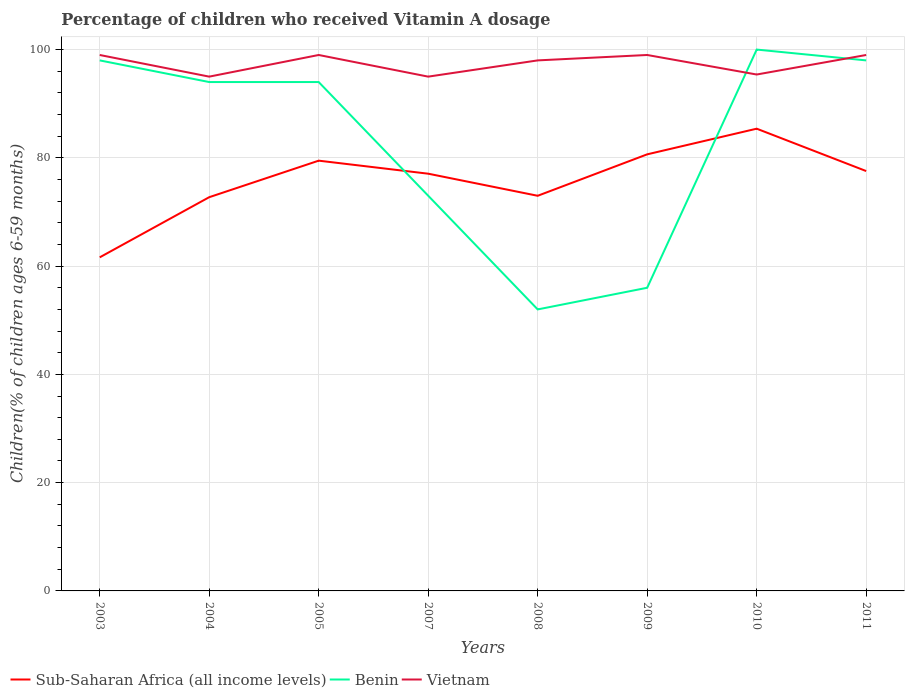How many different coloured lines are there?
Keep it short and to the point. 3. Across all years, what is the maximum percentage of children who received Vitamin A dosage in Sub-Saharan Africa (all income levels)?
Your answer should be compact. 61.62. What is the total percentage of children who received Vitamin A dosage in Sub-Saharan Africa (all income levels) in the graph?
Give a very brief answer. -7.66. What is the difference between the highest and the second highest percentage of children who received Vitamin A dosage in Benin?
Your response must be concise. 48. What is the difference between the highest and the lowest percentage of children who received Vitamin A dosage in Sub-Saharan Africa (all income levels)?
Keep it short and to the point. 5. Are the values on the major ticks of Y-axis written in scientific E-notation?
Make the answer very short. No. Does the graph contain any zero values?
Your response must be concise. No. Does the graph contain grids?
Your response must be concise. Yes. How are the legend labels stacked?
Make the answer very short. Horizontal. What is the title of the graph?
Your answer should be compact. Percentage of children who received Vitamin A dosage. Does "Latin America(all income levels)" appear as one of the legend labels in the graph?
Keep it short and to the point. No. What is the label or title of the Y-axis?
Offer a very short reply. Children(% of children ages 6-59 months). What is the Children(% of children ages 6-59 months) of Sub-Saharan Africa (all income levels) in 2003?
Your answer should be compact. 61.62. What is the Children(% of children ages 6-59 months) of Sub-Saharan Africa (all income levels) in 2004?
Your response must be concise. 72.73. What is the Children(% of children ages 6-59 months) of Benin in 2004?
Provide a short and direct response. 94. What is the Children(% of children ages 6-59 months) of Sub-Saharan Africa (all income levels) in 2005?
Offer a terse response. 79.48. What is the Children(% of children ages 6-59 months) of Benin in 2005?
Offer a terse response. 94. What is the Children(% of children ages 6-59 months) of Vietnam in 2005?
Your response must be concise. 99. What is the Children(% of children ages 6-59 months) in Sub-Saharan Africa (all income levels) in 2007?
Make the answer very short. 77.07. What is the Children(% of children ages 6-59 months) in Benin in 2007?
Ensure brevity in your answer.  73. What is the Children(% of children ages 6-59 months) in Sub-Saharan Africa (all income levels) in 2008?
Your answer should be compact. 72.99. What is the Children(% of children ages 6-59 months) of Vietnam in 2008?
Keep it short and to the point. 98. What is the Children(% of children ages 6-59 months) in Sub-Saharan Africa (all income levels) in 2009?
Your answer should be very brief. 80.65. What is the Children(% of children ages 6-59 months) of Vietnam in 2009?
Offer a terse response. 99. What is the Children(% of children ages 6-59 months) of Sub-Saharan Africa (all income levels) in 2010?
Offer a very short reply. 85.38. What is the Children(% of children ages 6-59 months) of Benin in 2010?
Ensure brevity in your answer.  100. What is the Children(% of children ages 6-59 months) of Vietnam in 2010?
Your response must be concise. 95.39. What is the Children(% of children ages 6-59 months) of Sub-Saharan Africa (all income levels) in 2011?
Ensure brevity in your answer.  77.56. What is the Children(% of children ages 6-59 months) in Benin in 2011?
Provide a succinct answer. 98. What is the Children(% of children ages 6-59 months) in Vietnam in 2011?
Provide a short and direct response. 99. Across all years, what is the maximum Children(% of children ages 6-59 months) of Sub-Saharan Africa (all income levels)?
Ensure brevity in your answer.  85.38. Across all years, what is the maximum Children(% of children ages 6-59 months) of Benin?
Offer a very short reply. 100. Across all years, what is the minimum Children(% of children ages 6-59 months) of Sub-Saharan Africa (all income levels)?
Your answer should be very brief. 61.62. Across all years, what is the minimum Children(% of children ages 6-59 months) in Benin?
Offer a very short reply. 52. What is the total Children(% of children ages 6-59 months) in Sub-Saharan Africa (all income levels) in the graph?
Your answer should be compact. 607.48. What is the total Children(% of children ages 6-59 months) of Benin in the graph?
Keep it short and to the point. 665. What is the total Children(% of children ages 6-59 months) of Vietnam in the graph?
Give a very brief answer. 779.39. What is the difference between the Children(% of children ages 6-59 months) in Sub-Saharan Africa (all income levels) in 2003 and that in 2004?
Keep it short and to the point. -11.11. What is the difference between the Children(% of children ages 6-59 months) of Benin in 2003 and that in 2004?
Your response must be concise. 4. What is the difference between the Children(% of children ages 6-59 months) in Sub-Saharan Africa (all income levels) in 2003 and that in 2005?
Keep it short and to the point. -17.86. What is the difference between the Children(% of children ages 6-59 months) of Vietnam in 2003 and that in 2005?
Your answer should be very brief. 0. What is the difference between the Children(% of children ages 6-59 months) of Sub-Saharan Africa (all income levels) in 2003 and that in 2007?
Make the answer very short. -15.45. What is the difference between the Children(% of children ages 6-59 months) in Vietnam in 2003 and that in 2007?
Provide a short and direct response. 4. What is the difference between the Children(% of children ages 6-59 months) of Sub-Saharan Africa (all income levels) in 2003 and that in 2008?
Offer a terse response. -11.37. What is the difference between the Children(% of children ages 6-59 months) of Benin in 2003 and that in 2008?
Provide a short and direct response. 46. What is the difference between the Children(% of children ages 6-59 months) in Sub-Saharan Africa (all income levels) in 2003 and that in 2009?
Keep it short and to the point. -19.03. What is the difference between the Children(% of children ages 6-59 months) in Benin in 2003 and that in 2009?
Give a very brief answer. 42. What is the difference between the Children(% of children ages 6-59 months) in Sub-Saharan Africa (all income levels) in 2003 and that in 2010?
Your answer should be very brief. -23.77. What is the difference between the Children(% of children ages 6-59 months) in Benin in 2003 and that in 2010?
Offer a very short reply. -2. What is the difference between the Children(% of children ages 6-59 months) in Vietnam in 2003 and that in 2010?
Make the answer very short. 3.61. What is the difference between the Children(% of children ages 6-59 months) of Sub-Saharan Africa (all income levels) in 2003 and that in 2011?
Provide a short and direct response. -15.94. What is the difference between the Children(% of children ages 6-59 months) in Sub-Saharan Africa (all income levels) in 2004 and that in 2005?
Provide a succinct answer. -6.75. What is the difference between the Children(% of children ages 6-59 months) of Vietnam in 2004 and that in 2005?
Offer a terse response. -4. What is the difference between the Children(% of children ages 6-59 months) of Sub-Saharan Africa (all income levels) in 2004 and that in 2007?
Your response must be concise. -4.34. What is the difference between the Children(% of children ages 6-59 months) of Sub-Saharan Africa (all income levels) in 2004 and that in 2008?
Your response must be concise. -0.26. What is the difference between the Children(% of children ages 6-59 months) in Sub-Saharan Africa (all income levels) in 2004 and that in 2009?
Offer a very short reply. -7.92. What is the difference between the Children(% of children ages 6-59 months) in Benin in 2004 and that in 2009?
Your answer should be very brief. 38. What is the difference between the Children(% of children ages 6-59 months) of Sub-Saharan Africa (all income levels) in 2004 and that in 2010?
Your answer should be compact. -12.65. What is the difference between the Children(% of children ages 6-59 months) of Benin in 2004 and that in 2010?
Your response must be concise. -6. What is the difference between the Children(% of children ages 6-59 months) in Vietnam in 2004 and that in 2010?
Your answer should be very brief. -0.39. What is the difference between the Children(% of children ages 6-59 months) in Sub-Saharan Africa (all income levels) in 2004 and that in 2011?
Keep it short and to the point. -4.83. What is the difference between the Children(% of children ages 6-59 months) of Sub-Saharan Africa (all income levels) in 2005 and that in 2007?
Offer a terse response. 2.41. What is the difference between the Children(% of children ages 6-59 months) in Vietnam in 2005 and that in 2007?
Make the answer very short. 4. What is the difference between the Children(% of children ages 6-59 months) in Sub-Saharan Africa (all income levels) in 2005 and that in 2008?
Offer a very short reply. 6.49. What is the difference between the Children(% of children ages 6-59 months) of Benin in 2005 and that in 2008?
Your answer should be compact. 42. What is the difference between the Children(% of children ages 6-59 months) in Vietnam in 2005 and that in 2008?
Ensure brevity in your answer.  1. What is the difference between the Children(% of children ages 6-59 months) in Sub-Saharan Africa (all income levels) in 2005 and that in 2009?
Provide a succinct answer. -1.17. What is the difference between the Children(% of children ages 6-59 months) in Benin in 2005 and that in 2009?
Make the answer very short. 38. What is the difference between the Children(% of children ages 6-59 months) of Sub-Saharan Africa (all income levels) in 2005 and that in 2010?
Ensure brevity in your answer.  -5.91. What is the difference between the Children(% of children ages 6-59 months) in Vietnam in 2005 and that in 2010?
Make the answer very short. 3.61. What is the difference between the Children(% of children ages 6-59 months) of Sub-Saharan Africa (all income levels) in 2005 and that in 2011?
Your answer should be compact. 1.92. What is the difference between the Children(% of children ages 6-59 months) of Benin in 2005 and that in 2011?
Keep it short and to the point. -4. What is the difference between the Children(% of children ages 6-59 months) in Vietnam in 2005 and that in 2011?
Give a very brief answer. 0. What is the difference between the Children(% of children ages 6-59 months) in Sub-Saharan Africa (all income levels) in 2007 and that in 2008?
Your response must be concise. 4.08. What is the difference between the Children(% of children ages 6-59 months) in Benin in 2007 and that in 2008?
Provide a short and direct response. 21. What is the difference between the Children(% of children ages 6-59 months) in Sub-Saharan Africa (all income levels) in 2007 and that in 2009?
Keep it short and to the point. -3.58. What is the difference between the Children(% of children ages 6-59 months) of Vietnam in 2007 and that in 2009?
Your response must be concise. -4. What is the difference between the Children(% of children ages 6-59 months) of Sub-Saharan Africa (all income levels) in 2007 and that in 2010?
Your response must be concise. -8.31. What is the difference between the Children(% of children ages 6-59 months) of Benin in 2007 and that in 2010?
Ensure brevity in your answer.  -27. What is the difference between the Children(% of children ages 6-59 months) in Vietnam in 2007 and that in 2010?
Provide a short and direct response. -0.39. What is the difference between the Children(% of children ages 6-59 months) in Sub-Saharan Africa (all income levels) in 2007 and that in 2011?
Your answer should be compact. -0.49. What is the difference between the Children(% of children ages 6-59 months) of Vietnam in 2007 and that in 2011?
Make the answer very short. -4. What is the difference between the Children(% of children ages 6-59 months) in Sub-Saharan Africa (all income levels) in 2008 and that in 2009?
Offer a terse response. -7.66. What is the difference between the Children(% of children ages 6-59 months) of Sub-Saharan Africa (all income levels) in 2008 and that in 2010?
Ensure brevity in your answer.  -12.39. What is the difference between the Children(% of children ages 6-59 months) in Benin in 2008 and that in 2010?
Your response must be concise. -48. What is the difference between the Children(% of children ages 6-59 months) in Vietnam in 2008 and that in 2010?
Provide a succinct answer. 2.61. What is the difference between the Children(% of children ages 6-59 months) in Sub-Saharan Africa (all income levels) in 2008 and that in 2011?
Give a very brief answer. -4.57. What is the difference between the Children(% of children ages 6-59 months) in Benin in 2008 and that in 2011?
Offer a very short reply. -46. What is the difference between the Children(% of children ages 6-59 months) in Sub-Saharan Africa (all income levels) in 2009 and that in 2010?
Offer a very short reply. -4.74. What is the difference between the Children(% of children ages 6-59 months) in Benin in 2009 and that in 2010?
Give a very brief answer. -44. What is the difference between the Children(% of children ages 6-59 months) of Vietnam in 2009 and that in 2010?
Offer a very short reply. 3.61. What is the difference between the Children(% of children ages 6-59 months) of Sub-Saharan Africa (all income levels) in 2009 and that in 2011?
Give a very brief answer. 3.09. What is the difference between the Children(% of children ages 6-59 months) in Benin in 2009 and that in 2011?
Your response must be concise. -42. What is the difference between the Children(% of children ages 6-59 months) of Sub-Saharan Africa (all income levels) in 2010 and that in 2011?
Your answer should be compact. 7.83. What is the difference between the Children(% of children ages 6-59 months) in Vietnam in 2010 and that in 2011?
Provide a short and direct response. -3.61. What is the difference between the Children(% of children ages 6-59 months) in Sub-Saharan Africa (all income levels) in 2003 and the Children(% of children ages 6-59 months) in Benin in 2004?
Your answer should be compact. -32.38. What is the difference between the Children(% of children ages 6-59 months) of Sub-Saharan Africa (all income levels) in 2003 and the Children(% of children ages 6-59 months) of Vietnam in 2004?
Your answer should be compact. -33.38. What is the difference between the Children(% of children ages 6-59 months) of Benin in 2003 and the Children(% of children ages 6-59 months) of Vietnam in 2004?
Your answer should be compact. 3. What is the difference between the Children(% of children ages 6-59 months) of Sub-Saharan Africa (all income levels) in 2003 and the Children(% of children ages 6-59 months) of Benin in 2005?
Provide a short and direct response. -32.38. What is the difference between the Children(% of children ages 6-59 months) of Sub-Saharan Africa (all income levels) in 2003 and the Children(% of children ages 6-59 months) of Vietnam in 2005?
Provide a short and direct response. -37.38. What is the difference between the Children(% of children ages 6-59 months) in Benin in 2003 and the Children(% of children ages 6-59 months) in Vietnam in 2005?
Offer a very short reply. -1. What is the difference between the Children(% of children ages 6-59 months) of Sub-Saharan Africa (all income levels) in 2003 and the Children(% of children ages 6-59 months) of Benin in 2007?
Your answer should be very brief. -11.38. What is the difference between the Children(% of children ages 6-59 months) of Sub-Saharan Africa (all income levels) in 2003 and the Children(% of children ages 6-59 months) of Vietnam in 2007?
Keep it short and to the point. -33.38. What is the difference between the Children(% of children ages 6-59 months) in Benin in 2003 and the Children(% of children ages 6-59 months) in Vietnam in 2007?
Offer a terse response. 3. What is the difference between the Children(% of children ages 6-59 months) in Sub-Saharan Africa (all income levels) in 2003 and the Children(% of children ages 6-59 months) in Benin in 2008?
Give a very brief answer. 9.62. What is the difference between the Children(% of children ages 6-59 months) of Sub-Saharan Africa (all income levels) in 2003 and the Children(% of children ages 6-59 months) of Vietnam in 2008?
Ensure brevity in your answer.  -36.38. What is the difference between the Children(% of children ages 6-59 months) of Sub-Saharan Africa (all income levels) in 2003 and the Children(% of children ages 6-59 months) of Benin in 2009?
Provide a short and direct response. 5.62. What is the difference between the Children(% of children ages 6-59 months) in Sub-Saharan Africa (all income levels) in 2003 and the Children(% of children ages 6-59 months) in Vietnam in 2009?
Provide a short and direct response. -37.38. What is the difference between the Children(% of children ages 6-59 months) of Benin in 2003 and the Children(% of children ages 6-59 months) of Vietnam in 2009?
Provide a short and direct response. -1. What is the difference between the Children(% of children ages 6-59 months) of Sub-Saharan Africa (all income levels) in 2003 and the Children(% of children ages 6-59 months) of Benin in 2010?
Provide a succinct answer. -38.38. What is the difference between the Children(% of children ages 6-59 months) in Sub-Saharan Africa (all income levels) in 2003 and the Children(% of children ages 6-59 months) in Vietnam in 2010?
Ensure brevity in your answer.  -33.77. What is the difference between the Children(% of children ages 6-59 months) in Benin in 2003 and the Children(% of children ages 6-59 months) in Vietnam in 2010?
Make the answer very short. 2.61. What is the difference between the Children(% of children ages 6-59 months) in Sub-Saharan Africa (all income levels) in 2003 and the Children(% of children ages 6-59 months) in Benin in 2011?
Offer a terse response. -36.38. What is the difference between the Children(% of children ages 6-59 months) of Sub-Saharan Africa (all income levels) in 2003 and the Children(% of children ages 6-59 months) of Vietnam in 2011?
Make the answer very short. -37.38. What is the difference between the Children(% of children ages 6-59 months) in Benin in 2003 and the Children(% of children ages 6-59 months) in Vietnam in 2011?
Make the answer very short. -1. What is the difference between the Children(% of children ages 6-59 months) in Sub-Saharan Africa (all income levels) in 2004 and the Children(% of children ages 6-59 months) in Benin in 2005?
Give a very brief answer. -21.27. What is the difference between the Children(% of children ages 6-59 months) of Sub-Saharan Africa (all income levels) in 2004 and the Children(% of children ages 6-59 months) of Vietnam in 2005?
Offer a terse response. -26.27. What is the difference between the Children(% of children ages 6-59 months) of Sub-Saharan Africa (all income levels) in 2004 and the Children(% of children ages 6-59 months) of Benin in 2007?
Provide a short and direct response. -0.27. What is the difference between the Children(% of children ages 6-59 months) of Sub-Saharan Africa (all income levels) in 2004 and the Children(% of children ages 6-59 months) of Vietnam in 2007?
Keep it short and to the point. -22.27. What is the difference between the Children(% of children ages 6-59 months) of Sub-Saharan Africa (all income levels) in 2004 and the Children(% of children ages 6-59 months) of Benin in 2008?
Your answer should be very brief. 20.73. What is the difference between the Children(% of children ages 6-59 months) of Sub-Saharan Africa (all income levels) in 2004 and the Children(% of children ages 6-59 months) of Vietnam in 2008?
Your response must be concise. -25.27. What is the difference between the Children(% of children ages 6-59 months) in Sub-Saharan Africa (all income levels) in 2004 and the Children(% of children ages 6-59 months) in Benin in 2009?
Offer a terse response. 16.73. What is the difference between the Children(% of children ages 6-59 months) in Sub-Saharan Africa (all income levels) in 2004 and the Children(% of children ages 6-59 months) in Vietnam in 2009?
Provide a succinct answer. -26.27. What is the difference between the Children(% of children ages 6-59 months) of Benin in 2004 and the Children(% of children ages 6-59 months) of Vietnam in 2009?
Provide a short and direct response. -5. What is the difference between the Children(% of children ages 6-59 months) of Sub-Saharan Africa (all income levels) in 2004 and the Children(% of children ages 6-59 months) of Benin in 2010?
Keep it short and to the point. -27.27. What is the difference between the Children(% of children ages 6-59 months) of Sub-Saharan Africa (all income levels) in 2004 and the Children(% of children ages 6-59 months) of Vietnam in 2010?
Provide a short and direct response. -22.66. What is the difference between the Children(% of children ages 6-59 months) of Benin in 2004 and the Children(% of children ages 6-59 months) of Vietnam in 2010?
Keep it short and to the point. -1.39. What is the difference between the Children(% of children ages 6-59 months) in Sub-Saharan Africa (all income levels) in 2004 and the Children(% of children ages 6-59 months) in Benin in 2011?
Keep it short and to the point. -25.27. What is the difference between the Children(% of children ages 6-59 months) of Sub-Saharan Africa (all income levels) in 2004 and the Children(% of children ages 6-59 months) of Vietnam in 2011?
Keep it short and to the point. -26.27. What is the difference between the Children(% of children ages 6-59 months) of Sub-Saharan Africa (all income levels) in 2005 and the Children(% of children ages 6-59 months) of Benin in 2007?
Provide a succinct answer. 6.48. What is the difference between the Children(% of children ages 6-59 months) in Sub-Saharan Africa (all income levels) in 2005 and the Children(% of children ages 6-59 months) in Vietnam in 2007?
Provide a succinct answer. -15.52. What is the difference between the Children(% of children ages 6-59 months) in Benin in 2005 and the Children(% of children ages 6-59 months) in Vietnam in 2007?
Provide a succinct answer. -1. What is the difference between the Children(% of children ages 6-59 months) in Sub-Saharan Africa (all income levels) in 2005 and the Children(% of children ages 6-59 months) in Benin in 2008?
Your answer should be compact. 27.48. What is the difference between the Children(% of children ages 6-59 months) in Sub-Saharan Africa (all income levels) in 2005 and the Children(% of children ages 6-59 months) in Vietnam in 2008?
Offer a terse response. -18.52. What is the difference between the Children(% of children ages 6-59 months) of Benin in 2005 and the Children(% of children ages 6-59 months) of Vietnam in 2008?
Ensure brevity in your answer.  -4. What is the difference between the Children(% of children ages 6-59 months) in Sub-Saharan Africa (all income levels) in 2005 and the Children(% of children ages 6-59 months) in Benin in 2009?
Ensure brevity in your answer.  23.48. What is the difference between the Children(% of children ages 6-59 months) in Sub-Saharan Africa (all income levels) in 2005 and the Children(% of children ages 6-59 months) in Vietnam in 2009?
Offer a terse response. -19.52. What is the difference between the Children(% of children ages 6-59 months) of Sub-Saharan Africa (all income levels) in 2005 and the Children(% of children ages 6-59 months) of Benin in 2010?
Your answer should be compact. -20.52. What is the difference between the Children(% of children ages 6-59 months) of Sub-Saharan Africa (all income levels) in 2005 and the Children(% of children ages 6-59 months) of Vietnam in 2010?
Your answer should be compact. -15.91. What is the difference between the Children(% of children ages 6-59 months) in Benin in 2005 and the Children(% of children ages 6-59 months) in Vietnam in 2010?
Your answer should be very brief. -1.39. What is the difference between the Children(% of children ages 6-59 months) of Sub-Saharan Africa (all income levels) in 2005 and the Children(% of children ages 6-59 months) of Benin in 2011?
Keep it short and to the point. -18.52. What is the difference between the Children(% of children ages 6-59 months) in Sub-Saharan Africa (all income levels) in 2005 and the Children(% of children ages 6-59 months) in Vietnam in 2011?
Give a very brief answer. -19.52. What is the difference between the Children(% of children ages 6-59 months) of Benin in 2005 and the Children(% of children ages 6-59 months) of Vietnam in 2011?
Your answer should be very brief. -5. What is the difference between the Children(% of children ages 6-59 months) of Sub-Saharan Africa (all income levels) in 2007 and the Children(% of children ages 6-59 months) of Benin in 2008?
Give a very brief answer. 25.07. What is the difference between the Children(% of children ages 6-59 months) in Sub-Saharan Africa (all income levels) in 2007 and the Children(% of children ages 6-59 months) in Vietnam in 2008?
Your answer should be very brief. -20.93. What is the difference between the Children(% of children ages 6-59 months) of Sub-Saharan Africa (all income levels) in 2007 and the Children(% of children ages 6-59 months) of Benin in 2009?
Give a very brief answer. 21.07. What is the difference between the Children(% of children ages 6-59 months) of Sub-Saharan Africa (all income levels) in 2007 and the Children(% of children ages 6-59 months) of Vietnam in 2009?
Provide a succinct answer. -21.93. What is the difference between the Children(% of children ages 6-59 months) in Benin in 2007 and the Children(% of children ages 6-59 months) in Vietnam in 2009?
Keep it short and to the point. -26. What is the difference between the Children(% of children ages 6-59 months) in Sub-Saharan Africa (all income levels) in 2007 and the Children(% of children ages 6-59 months) in Benin in 2010?
Your response must be concise. -22.93. What is the difference between the Children(% of children ages 6-59 months) in Sub-Saharan Africa (all income levels) in 2007 and the Children(% of children ages 6-59 months) in Vietnam in 2010?
Your response must be concise. -18.32. What is the difference between the Children(% of children ages 6-59 months) of Benin in 2007 and the Children(% of children ages 6-59 months) of Vietnam in 2010?
Your answer should be compact. -22.39. What is the difference between the Children(% of children ages 6-59 months) in Sub-Saharan Africa (all income levels) in 2007 and the Children(% of children ages 6-59 months) in Benin in 2011?
Offer a terse response. -20.93. What is the difference between the Children(% of children ages 6-59 months) in Sub-Saharan Africa (all income levels) in 2007 and the Children(% of children ages 6-59 months) in Vietnam in 2011?
Your answer should be very brief. -21.93. What is the difference between the Children(% of children ages 6-59 months) in Benin in 2007 and the Children(% of children ages 6-59 months) in Vietnam in 2011?
Provide a short and direct response. -26. What is the difference between the Children(% of children ages 6-59 months) in Sub-Saharan Africa (all income levels) in 2008 and the Children(% of children ages 6-59 months) in Benin in 2009?
Make the answer very short. 16.99. What is the difference between the Children(% of children ages 6-59 months) of Sub-Saharan Africa (all income levels) in 2008 and the Children(% of children ages 6-59 months) of Vietnam in 2009?
Give a very brief answer. -26.01. What is the difference between the Children(% of children ages 6-59 months) of Benin in 2008 and the Children(% of children ages 6-59 months) of Vietnam in 2009?
Offer a terse response. -47. What is the difference between the Children(% of children ages 6-59 months) in Sub-Saharan Africa (all income levels) in 2008 and the Children(% of children ages 6-59 months) in Benin in 2010?
Your answer should be compact. -27.01. What is the difference between the Children(% of children ages 6-59 months) in Sub-Saharan Africa (all income levels) in 2008 and the Children(% of children ages 6-59 months) in Vietnam in 2010?
Offer a very short reply. -22.4. What is the difference between the Children(% of children ages 6-59 months) of Benin in 2008 and the Children(% of children ages 6-59 months) of Vietnam in 2010?
Your answer should be compact. -43.39. What is the difference between the Children(% of children ages 6-59 months) of Sub-Saharan Africa (all income levels) in 2008 and the Children(% of children ages 6-59 months) of Benin in 2011?
Offer a very short reply. -25.01. What is the difference between the Children(% of children ages 6-59 months) of Sub-Saharan Africa (all income levels) in 2008 and the Children(% of children ages 6-59 months) of Vietnam in 2011?
Your answer should be compact. -26.01. What is the difference between the Children(% of children ages 6-59 months) of Benin in 2008 and the Children(% of children ages 6-59 months) of Vietnam in 2011?
Offer a very short reply. -47. What is the difference between the Children(% of children ages 6-59 months) in Sub-Saharan Africa (all income levels) in 2009 and the Children(% of children ages 6-59 months) in Benin in 2010?
Ensure brevity in your answer.  -19.35. What is the difference between the Children(% of children ages 6-59 months) of Sub-Saharan Africa (all income levels) in 2009 and the Children(% of children ages 6-59 months) of Vietnam in 2010?
Ensure brevity in your answer.  -14.74. What is the difference between the Children(% of children ages 6-59 months) of Benin in 2009 and the Children(% of children ages 6-59 months) of Vietnam in 2010?
Give a very brief answer. -39.39. What is the difference between the Children(% of children ages 6-59 months) in Sub-Saharan Africa (all income levels) in 2009 and the Children(% of children ages 6-59 months) in Benin in 2011?
Make the answer very short. -17.35. What is the difference between the Children(% of children ages 6-59 months) in Sub-Saharan Africa (all income levels) in 2009 and the Children(% of children ages 6-59 months) in Vietnam in 2011?
Your answer should be compact. -18.35. What is the difference between the Children(% of children ages 6-59 months) in Benin in 2009 and the Children(% of children ages 6-59 months) in Vietnam in 2011?
Make the answer very short. -43. What is the difference between the Children(% of children ages 6-59 months) in Sub-Saharan Africa (all income levels) in 2010 and the Children(% of children ages 6-59 months) in Benin in 2011?
Your answer should be compact. -12.62. What is the difference between the Children(% of children ages 6-59 months) in Sub-Saharan Africa (all income levels) in 2010 and the Children(% of children ages 6-59 months) in Vietnam in 2011?
Provide a short and direct response. -13.62. What is the difference between the Children(% of children ages 6-59 months) of Benin in 2010 and the Children(% of children ages 6-59 months) of Vietnam in 2011?
Your response must be concise. 1. What is the average Children(% of children ages 6-59 months) of Sub-Saharan Africa (all income levels) per year?
Ensure brevity in your answer.  75.94. What is the average Children(% of children ages 6-59 months) of Benin per year?
Provide a succinct answer. 83.12. What is the average Children(% of children ages 6-59 months) in Vietnam per year?
Ensure brevity in your answer.  97.42. In the year 2003, what is the difference between the Children(% of children ages 6-59 months) of Sub-Saharan Africa (all income levels) and Children(% of children ages 6-59 months) of Benin?
Your answer should be very brief. -36.38. In the year 2003, what is the difference between the Children(% of children ages 6-59 months) in Sub-Saharan Africa (all income levels) and Children(% of children ages 6-59 months) in Vietnam?
Your answer should be compact. -37.38. In the year 2003, what is the difference between the Children(% of children ages 6-59 months) in Benin and Children(% of children ages 6-59 months) in Vietnam?
Your answer should be very brief. -1. In the year 2004, what is the difference between the Children(% of children ages 6-59 months) in Sub-Saharan Africa (all income levels) and Children(% of children ages 6-59 months) in Benin?
Ensure brevity in your answer.  -21.27. In the year 2004, what is the difference between the Children(% of children ages 6-59 months) of Sub-Saharan Africa (all income levels) and Children(% of children ages 6-59 months) of Vietnam?
Offer a terse response. -22.27. In the year 2005, what is the difference between the Children(% of children ages 6-59 months) of Sub-Saharan Africa (all income levels) and Children(% of children ages 6-59 months) of Benin?
Your answer should be very brief. -14.52. In the year 2005, what is the difference between the Children(% of children ages 6-59 months) in Sub-Saharan Africa (all income levels) and Children(% of children ages 6-59 months) in Vietnam?
Provide a succinct answer. -19.52. In the year 2007, what is the difference between the Children(% of children ages 6-59 months) of Sub-Saharan Africa (all income levels) and Children(% of children ages 6-59 months) of Benin?
Your answer should be very brief. 4.07. In the year 2007, what is the difference between the Children(% of children ages 6-59 months) of Sub-Saharan Africa (all income levels) and Children(% of children ages 6-59 months) of Vietnam?
Offer a very short reply. -17.93. In the year 2008, what is the difference between the Children(% of children ages 6-59 months) of Sub-Saharan Africa (all income levels) and Children(% of children ages 6-59 months) of Benin?
Your answer should be compact. 20.99. In the year 2008, what is the difference between the Children(% of children ages 6-59 months) of Sub-Saharan Africa (all income levels) and Children(% of children ages 6-59 months) of Vietnam?
Offer a very short reply. -25.01. In the year 2008, what is the difference between the Children(% of children ages 6-59 months) of Benin and Children(% of children ages 6-59 months) of Vietnam?
Make the answer very short. -46. In the year 2009, what is the difference between the Children(% of children ages 6-59 months) in Sub-Saharan Africa (all income levels) and Children(% of children ages 6-59 months) in Benin?
Keep it short and to the point. 24.65. In the year 2009, what is the difference between the Children(% of children ages 6-59 months) in Sub-Saharan Africa (all income levels) and Children(% of children ages 6-59 months) in Vietnam?
Provide a succinct answer. -18.35. In the year 2009, what is the difference between the Children(% of children ages 6-59 months) in Benin and Children(% of children ages 6-59 months) in Vietnam?
Provide a short and direct response. -43. In the year 2010, what is the difference between the Children(% of children ages 6-59 months) of Sub-Saharan Africa (all income levels) and Children(% of children ages 6-59 months) of Benin?
Your answer should be very brief. -14.62. In the year 2010, what is the difference between the Children(% of children ages 6-59 months) in Sub-Saharan Africa (all income levels) and Children(% of children ages 6-59 months) in Vietnam?
Provide a succinct answer. -10.01. In the year 2010, what is the difference between the Children(% of children ages 6-59 months) in Benin and Children(% of children ages 6-59 months) in Vietnam?
Offer a very short reply. 4.61. In the year 2011, what is the difference between the Children(% of children ages 6-59 months) of Sub-Saharan Africa (all income levels) and Children(% of children ages 6-59 months) of Benin?
Provide a succinct answer. -20.44. In the year 2011, what is the difference between the Children(% of children ages 6-59 months) in Sub-Saharan Africa (all income levels) and Children(% of children ages 6-59 months) in Vietnam?
Your response must be concise. -21.44. In the year 2011, what is the difference between the Children(% of children ages 6-59 months) of Benin and Children(% of children ages 6-59 months) of Vietnam?
Offer a terse response. -1. What is the ratio of the Children(% of children ages 6-59 months) of Sub-Saharan Africa (all income levels) in 2003 to that in 2004?
Ensure brevity in your answer.  0.85. What is the ratio of the Children(% of children ages 6-59 months) in Benin in 2003 to that in 2004?
Offer a terse response. 1.04. What is the ratio of the Children(% of children ages 6-59 months) in Vietnam in 2003 to that in 2004?
Provide a short and direct response. 1.04. What is the ratio of the Children(% of children ages 6-59 months) of Sub-Saharan Africa (all income levels) in 2003 to that in 2005?
Provide a short and direct response. 0.78. What is the ratio of the Children(% of children ages 6-59 months) of Benin in 2003 to that in 2005?
Your response must be concise. 1.04. What is the ratio of the Children(% of children ages 6-59 months) of Sub-Saharan Africa (all income levels) in 2003 to that in 2007?
Your response must be concise. 0.8. What is the ratio of the Children(% of children ages 6-59 months) in Benin in 2003 to that in 2007?
Keep it short and to the point. 1.34. What is the ratio of the Children(% of children ages 6-59 months) of Vietnam in 2003 to that in 2007?
Provide a short and direct response. 1.04. What is the ratio of the Children(% of children ages 6-59 months) in Sub-Saharan Africa (all income levels) in 2003 to that in 2008?
Keep it short and to the point. 0.84. What is the ratio of the Children(% of children ages 6-59 months) of Benin in 2003 to that in 2008?
Offer a very short reply. 1.88. What is the ratio of the Children(% of children ages 6-59 months) of Vietnam in 2003 to that in 2008?
Give a very brief answer. 1.01. What is the ratio of the Children(% of children ages 6-59 months) in Sub-Saharan Africa (all income levels) in 2003 to that in 2009?
Offer a very short reply. 0.76. What is the ratio of the Children(% of children ages 6-59 months) of Vietnam in 2003 to that in 2009?
Offer a very short reply. 1. What is the ratio of the Children(% of children ages 6-59 months) of Sub-Saharan Africa (all income levels) in 2003 to that in 2010?
Keep it short and to the point. 0.72. What is the ratio of the Children(% of children ages 6-59 months) in Benin in 2003 to that in 2010?
Provide a short and direct response. 0.98. What is the ratio of the Children(% of children ages 6-59 months) in Vietnam in 2003 to that in 2010?
Your response must be concise. 1.04. What is the ratio of the Children(% of children ages 6-59 months) of Sub-Saharan Africa (all income levels) in 2003 to that in 2011?
Offer a terse response. 0.79. What is the ratio of the Children(% of children ages 6-59 months) of Benin in 2003 to that in 2011?
Make the answer very short. 1. What is the ratio of the Children(% of children ages 6-59 months) in Vietnam in 2003 to that in 2011?
Offer a very short reply. 1. What is the ratio of the Children(% of children ages 6-59 months) of Sub-Saharan Africa (all income levels) in 2004 to that in 2005?
Your answer should be compact. 0.92. What is the ratio of the Children(% of children ages 6-59 months) in Benin in 2004 to that in 2005?
Ensure brevity in your answer.  1. What is the ratio of the Children(% of children ages 6-59 months) of Vietnam in 2004 to that in 2005?
Offer a very short reply. 0.96. What is the ratio of the Children(% of children ages 6-59 months) of Sub-Saharan Africa (all income levels) in 2004 to that in 2007?
Provide a succinct answer. 0.94. What is the ratio of the Children(% of children ages 6-59 months) in Benin in 2004 to that in 2007?
Your answer should be compact. 1.29. What is the ratio of the Children(% of children ages 6-59 months) of Vietnam in 2004 to that in 2007?
Ensure brevity in your answer.  1. What is the ratio of the Children(% of children ages 6-59 months) in Sub-Saharan Africa (all income levels) in 2004 to that in 2008?
Your answer should be very brief. 1. What is the ratio of the Children(% of children ages 6-59 months) of Benin in 2004 to that in 2008?
Give a very brief answer. 1.81. What is the ratio of the Children(% of children ages 6-59 months) in Vietnam in 2004 to that in 2008?
Make the answer very short. 0.97. What is the ratio of the Children(% of children ages 6-59 months) of Sub-Saharan Africa (all income levels) in 2004 to that in 2009?
Offer a very short reply. 0.9. What is the ratio of the Children(% of children ages 6-59 months) in Benin in 2004 to that in 2009?
Your answer should be compact. 1.68. What is the ratio of the Children(% of children ages 6-59 months) in Vietnam in 2004 to that in 2009?
Offer a very short reply. 0.96. What is the ratio of the Children(% of children ages 6-59 months) of Sub-Saharan Africa (all income levels) in 2004 to that in 2010?
Your response must be concise. 0.85. What is the ratio of the Children(% of children ages 6-59 months) of Sub-Saharan Africa (all income levels) in 2004 to that in 2011?
Make the answer very short. 0.94. What is the ratio of the Children(% of children ages 6-59 months) in Benin in 2004 to that in 2011?
Your answer should be very brief. 0.96. What is the ratio of the Children(% of children ages 6-59 months) of Vietnam in 2004 to that in 2011?
Give a very brief answer. 0.96. What is the ratio of the Children(% of children ages 6-59 months) of Sub-Saharan Africa (all income levels) in 2005 to that in 2007?
Your response must be concise. 1.03. What is the ratio of the Children(% of children ages 6-59 months) of Benin in 2005 to that in 2007?
Keep it short and to the point. 1.29. What is the ratio of the Children(% of children ages 6-59 months) of Vietnam in 2005 to that in 2007?
Offer a very short reply. 1.04. What is the ratio of the Children(% of children ages 6-59 months) in Sub-Saharan Africa (all income levels) in 2005 to that in 2008?
Make the answer very short. 1.09. What is the ratio of the Children(% of children ages 6-59 months) in Benin in 2005 to that in 2008?
Ensure brevity in your answer.  1.81. What is the ratio of the Children(% of children ages 6-59 months) in Vietnam in 2005 to that in 2008?
Your answer should be very brief. 1.01. What is the ratio of the Children(% of children ages 6-59 months) of Sub-Saharan Africa (all income levels) in 2005 to that in 2009?
Your answer should be very brief. 0.99. What is the ratio of the Children(% of children ages 6-59 months) in Benin in 2005 to that in 2009?
Your answer should be compact. 1.68. What is the ratio of the Children(% of children ages 6-59 months) of Vietnam in 2005 to that in 2009?
Your response must be concise. 1. What is the ratio of the Children(% of children ages 6-59 months) of Sub-Saharan Africa (all income levels) in 2005 to that in 2010?
Your answer should be compact. 0.93. What is the ratio of the Children(% of children ages 6-59 months) of Vietnam in 2005 to that in 2010?
Provide a short and direct response. 1.04. What is the ratio of the Children(% of children ages 6-59 months) in Sub-Saharan Africa (all income levels) in 2005 to that in 2011?
Your response must be concise. 1.02. What is the ratio of the Children(% of children ages 6-59 months) of Benin in 2005 to that in 2011?
Offer a terse response. 0.96. What is the ratio of the Children(% of children ages 6-59 months) in Sub-Saharan Africa (all income levels) in 2007 to that in 2008?
Provide a short and direct response. 1.06. What is the ratio of the Children(% of children ages 6-59 months) of Benin in 2007 to that in 2008?
Your response must be concise. 1.4. What is the ratio of the Children(% of children ages 6-59 months) in Vietnam in 2007 to that in 2008?
Offer a very short reply. 0.97. What is the ratio of the Children(% of children ages 6-59 months) in Sub-Saharan Africa (all income levels) in 2007 to that in 2009?
Make the answer very short. 0.96. What is the ratio of the Children(% of children ages 6-59 months) of Benin in 2007 to that in 2009?
Offer a very short reply. 1.3. What is the ratio of the Children(% of children ages 6-59 months) of Vietnam in 2007 to that in 2009?
Provide a succinct answer. 0.96. What is the ratio of the Children(% of children ages 6-59 months) of Sub-Saharan Africa (all income levels) in 2007 to that in 2010?
Offer a terse response. 0.9. What is the ratio of the Children(% of children ages 6-59 months) of Benin in 2007 to that in 2010?
Provide a short and direct response. 0.73. What is the ratio of the Children(% of children ages 6-59 months) of Vietnam in 2007 to that in 2010?
Offer a terse response. 1. What is the ratio of the Children(% of children ages 6-59 months) of Benin in 2007 to that in 2011?
Make the answer very short. 0.74. What is the ratio of the Children(% of children ages 6-59 months) in Vietnam in 2007 to that in 2011?
Offer a terse response. 0.96. What is the ratio of the Children(% of children ages 6-59 months) in Sub-Saharan Africa (all income levels) in 2008 to that in 2009?
Your answer should be compact. 0.91. What is the ratio of the Children(% of children ages 6-59 months) of Benin in 2008 to that in 2009?
Your answer should be very brief. 0.93. What is the ratio of the Children(% of children ages 6-59 months) of Sub-Saharan Africa (all income levels) in 2008 to that in 2010?
Your answer should be very brief. 0.85. What is the ratio of the Children(% of children ages 6-59 months) of Benin in 2008 to that in 2010?
Provide a succinct answer. 0.52. What is the ratio of the Children(% of children ages 6-59 months) of Vietnam in 2008 to that in 2010?
Give a very brief answer. 1.03. What is the ratio of the Children(% of children ages 6-59 months) in Sub-Saharan Africa (all income levels) in 2008 to that in 2011?
Provide a short and direct response. 0.94. What is the ratio of the Children(% of children ages 6-59 months) in Benin in 2008 to that in 2011?
Keep it short and to the point. 0.53. What is the ratio of the Children(% of children ages 6-59 months) in Vietnam in 2008 to that in 2011?
Make the answer very short. 0.99. What is the ratio of the Children(% of children ages 6-59 months) of Sub-Saharan Africa (all income levels) in 2009 to that in 2010?
Keep it short and to the point. 0.94. What is the ratio of the Children(% of children ages 6-59 months) in Benin in 2009 to that in 2010?
Make the answer very short. 0.56. What is the ratio of the Children(% of children ages 6-59 months) in Vietnam in 2009 to that in 2010?
Your answer should be compact. 1.04. What is the ratio of the Children(% of children ages 6-59 months) of Sub-Saharan Africa (all income levels) in 2009 to that in 2011?
Your response must be concise. 1.04. What is the ratio of the Children(% of children ages 6-59 months) of Benin in 2009 to that in 2011?
Provide a succinct answer. 0.57. What is the ratio of the Children(% of children ages 6-59 months) in Vietnam in 2009 to that in 2011?
Your response must be concise. 1. What is the ratio of the Children(% of children ages 6-59 months) in Sub-Saharan Africa (all income levels) in 2010 to that in 2011?
Offer a terse response. 1.1. What is the ratio of the Children(% of children ages 6-59 months) in Benin in 2010 to that in 2011?
Provide a succinct answer. 1.02. What is the ratio of the Children(% of children ages 6-59 months) in Vietnam in 2010 to that in 2011?
Give a very brief answer. 0.96. What is the difference between the highest and the second highest Children(% of children ages 6-59 months) in Sub-Saharan Africa (all income levels)?
Ensure brevity in your answer.  4.74. What is the difference between the highest and the second highest Children(% of children ages 6-59 months) of Benin?
Offer a terse response. 2. What is the difference between the highest and the second highest Children(% of children ages 6-59 months) of Vietnam?
Provide a succinct answer. 0. What is the difference between the highest and the lowest Children(% of children ages 6-59 months) in Sub-Saharan Africa (all income levels)?
Keep it short and to the point. 23.77. What is the difference between the highest and the lowest Children(% of children ages 6-59 months) of Benin?
Keep it short and to the point. 48. What is the difference between the highest and the lowest Children(% of children ages 6-59 months) of Vietnam?
Keep it short and to the point. 4. 